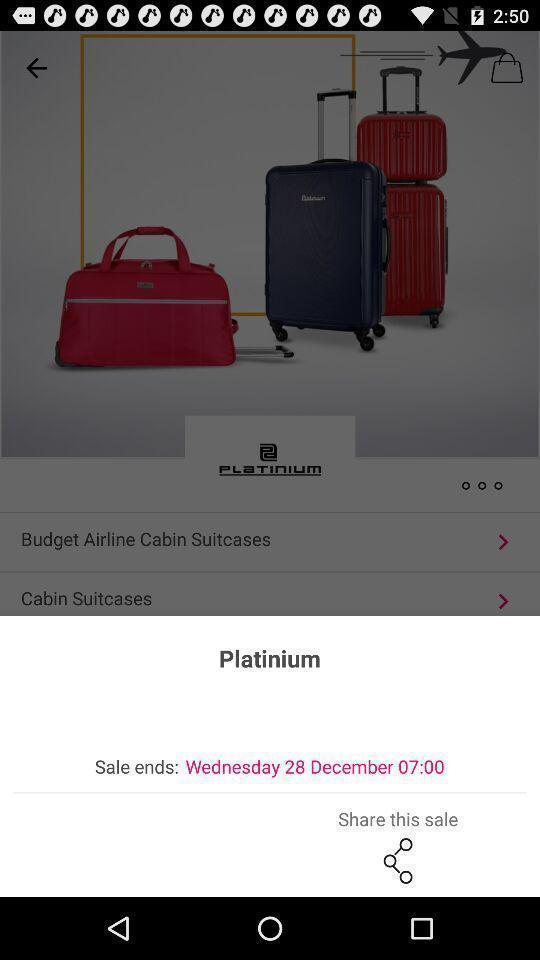Explain what's happening in this screen capture. Sales end of the platinum. 